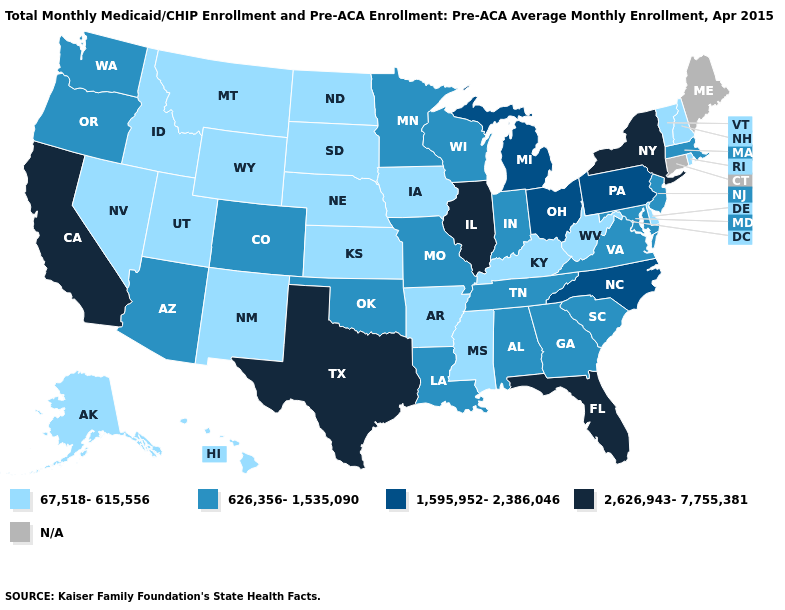Which states have the highest value in the USA?
Be succinct. California, Florida, Illinois, New York, Texas. What is the lowest value in the USA?
Give a very brief answer. 67,518-615,556. What is the value of Vermont?
Answer briefly. 67,518-615,556. Name the states that have a value in the range 1,595,952-2,386,046?
Write a very short answer. Michigan, North Carolina, Ohio, Pennsylvania. Does Texas have the highest value in the USA?
Quick response, please. Yes. What is the value of Rhode Island?
Be succinct. 67,518-615,556. What is the value of Pennsylvania?
Short answer required. 1,595,952-2,386,046. Which states hav the highest value in the MidWest?
Keep it brief. Illinois. Among the states that border Nebraska , does Missouri have the lowest value?
Answer briefly. No. What is the value of Wyoming?
Quick response, please. 67,518-615,556. Which states have the highest value in the USA?
Answer briefly. California, Florida, Illinois, New York, Texas. Which states have the lowest value in the South?
Be succinct. Arkansas, Delaware, Kentucky, Mississippi, West Virginia. What is the lowest value in the South?
Write a very short answer. 67,518-615,556. Is the legend a continuous bar?
Keep it brief. No. 